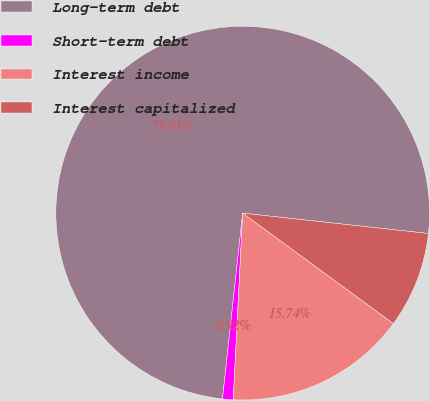<chart> <loc_0><loc_0><loc_500><loc_500><pie_chart><fcel>Long-term debt<fcel>Short-term debt<fcel>Interest income<fcel>Interest capitalized<nl><fcel>75.02%<fcel>0.92%<fcel>15.74%<fcel>8.33%<nl></chart> 